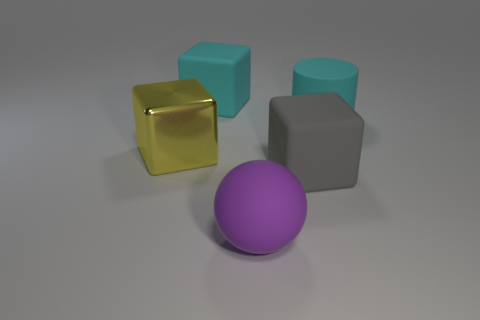Is there any other thing that has the same material as the large yellow thing?
Keep it short and to the point. No. Do the large gray cube and the large yellow object have the same material?
Your answer should be very brief. No. What number of things are either tiny purple spheres or gray objects?
Your answer should be compact. 1. What number of other objects are there of the same size as the purple matte object?
Ensure brevity in your answer.  4. There is a big rubber ball; is it the same color as the large rubber cube in front of the large shiny thing?
Your answer should be compact. No. How many cubes are either big gray rubber objects or big matte objects?
Offer a very short reply. 2. Is there anything else that is the same color as the big metal cube?
Provide a succinct answer. No. What is the thing that is to the left of the large cyan object that is on the left side of the big purple thing made of?
Provide a short and direct response. Metal. Do the big cyan block and the large block to the right of the matte ball have the same material?
Provide a succinct answer. Yes. What number of things are objects that are on the right side of the big gray matte block or purple matte objects?
Ensure brevity in your answer.  2. 